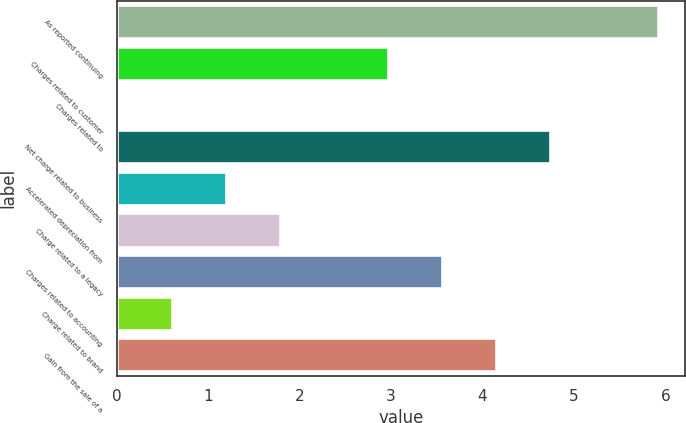Convert chart. <chart><loc_0><loc_0><loc_500><loc_500><bar_chart><fcel>As reported continuing<fcel>Charges related to customer<fcel>Charges related to<fcel>Net charge related to business<fcel>Accelerated depreciation from<fcel>Charge related to a legacy<fcel>Charges related to accounting<fcel>Charge related to brand<fcel>Gain from the sale of a<nl><fcel>5.92<fcel>2.97<fcel>0.02<fcel>4.74<fcel>1.2<fcel>1.79<fcel>3.56<fcel>0.61<fcel>4.15<nl></chart> 